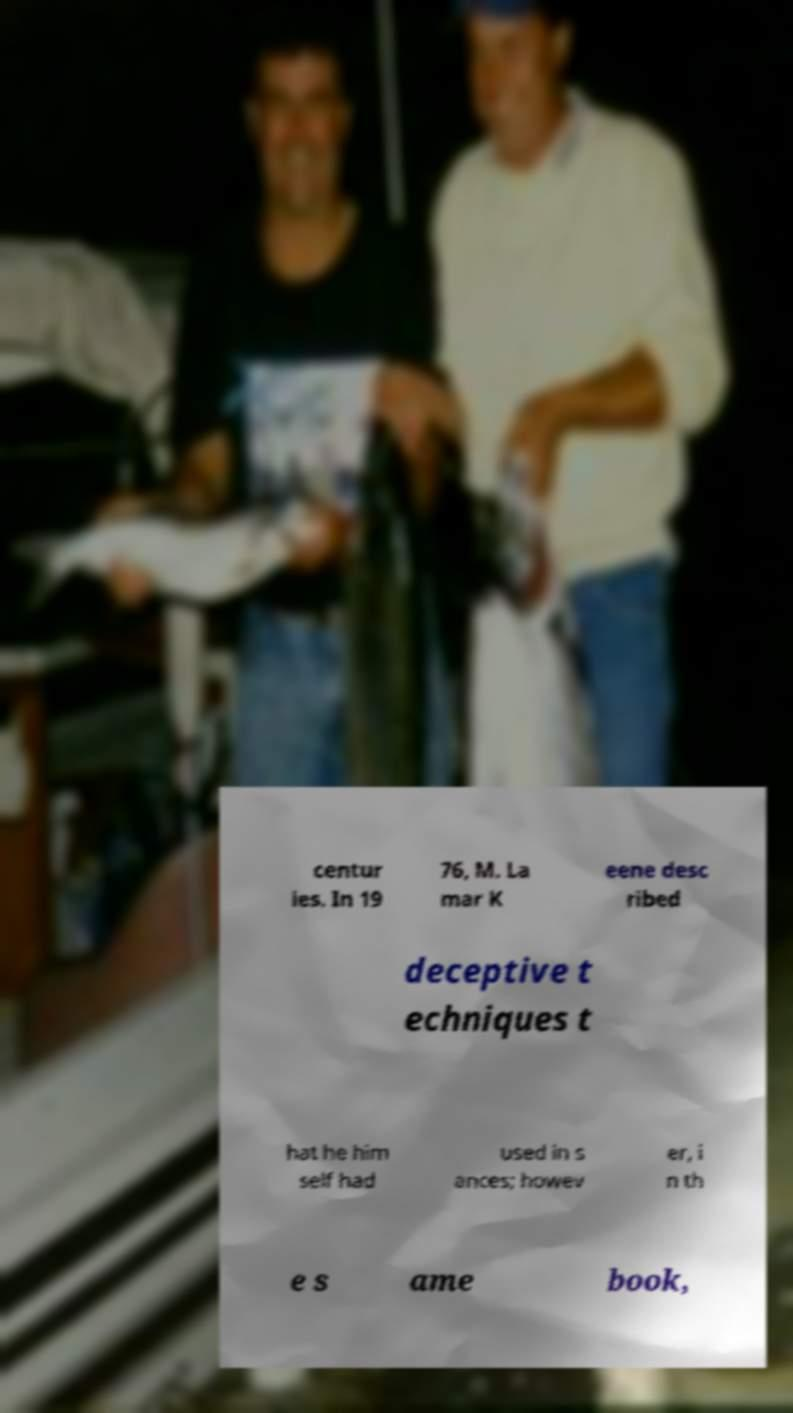Please identify and transcribe the text found in this image. centur ies. In 19 76, M. La mar K eene desc ribed deceptive t echniques t hat he him self had used in s ances; howev er, i n th e s ame book, 